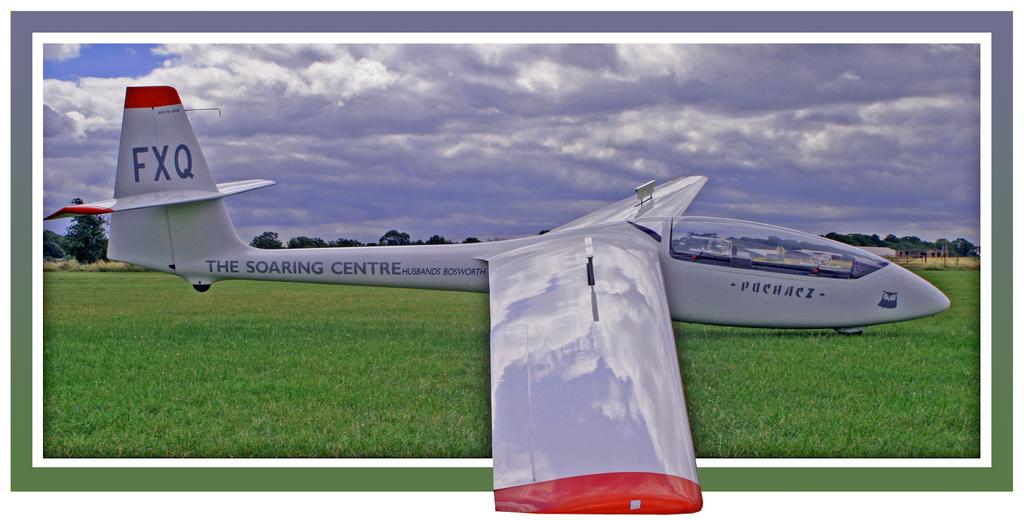What letters can you see on the very back of the plane?
Keep it short and to the point. Fxq. Which centre is featured on the plane?
Your answer should be very brief. The soaring centre. 